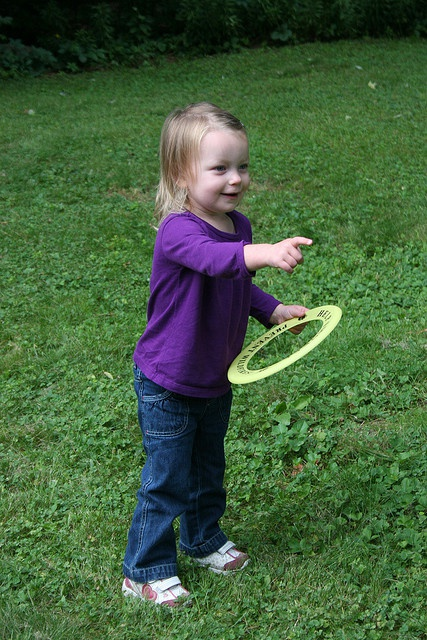Describe the objects in this image and their specific colors. I can see people in black, navy, purple, and gray tones and frisbee in black, khaki, green, darkgreen, and olive tones in this image. 